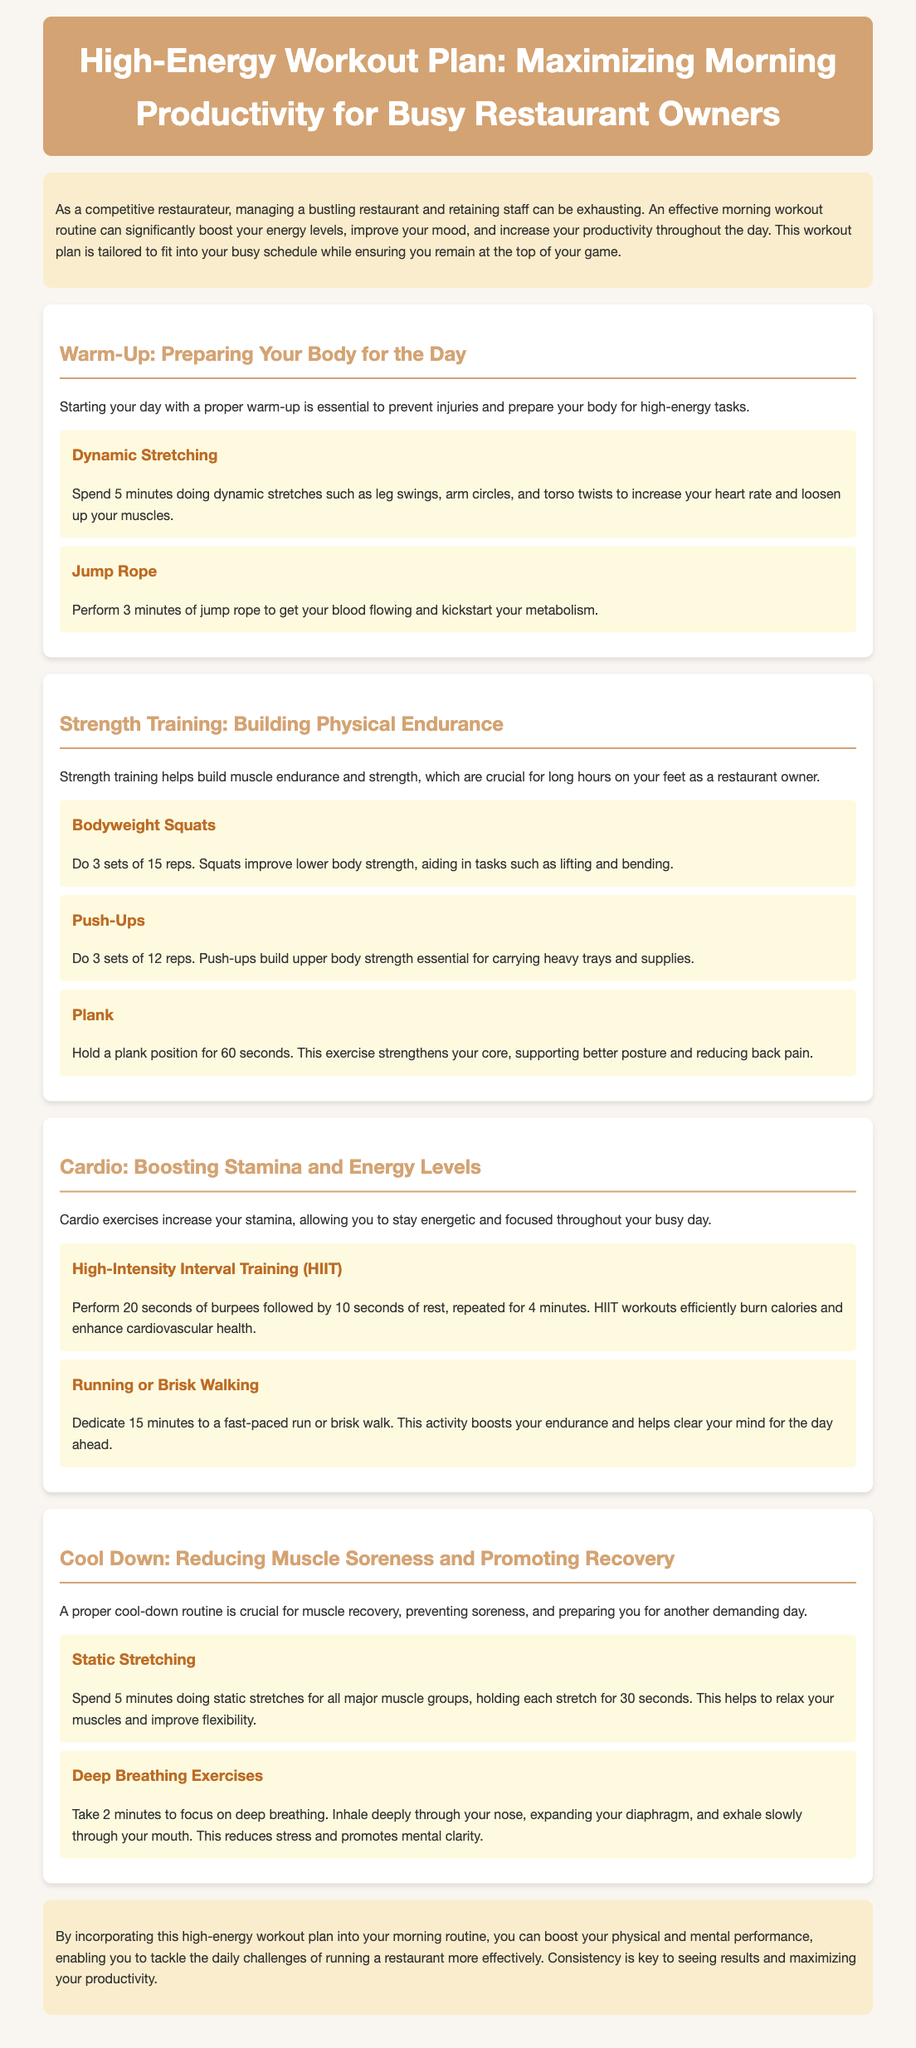What is the title of the workout plan? The title of the workout plan is presented at the top of the document, which is "High-Energy Workout Plan: Maximizing Morning Productivity for Busy Restaurant Owners."
Answer: High-Energy Workout Plan: Maximizing Morning Productivity for Busy Restaurant Owners How long should the warm-up last? The warm-up consists of various activities that should be done for a total time of about 8 minutes, combining dynamic stretching and jump rope.
Answer: 8 minutes What exercise should be performed for strength training? Strength training includes activities like bodyweight squats, push-ups, and planks; these are specified as part of the workout plan in the second section.
Answer: Bodyweight squats, push-ups, planks How many sets of push-ups are recommended? The document specifies a total number of sets for push-ups as part of the strength training section.
Answer: 3 sets What is one benefit of static stretching? The static stretching section highlights that these activities help to relax muscles and improve flexibility.
Answer: Improve flexibility What type of interval training is suggested? The document recommends High-Intensity Interval Training (HIIT) as part of the cardio section for boosting stamina and energy levels.
Answer: High-Intensity Interval Training (HIIT) How long should the running or brisk walking be? The recommended duration for running or brisk walking is mentioned as part of the cardio section in the workout plan.
Answer: 15 minutes What does the cool-down section focus on? The cool-down section is crucial for muscle recovery, preventing soreness, and preparing for another demanding day.
Answer: Muscle recovery, preventing soreness What is the main goal of the workout plan? The overall purpose of the workout plan is summarized in the introduction and closing, focusing on enhancing physical and mental performance for restaurant owners.
Answer: Boost physical and mental performance 